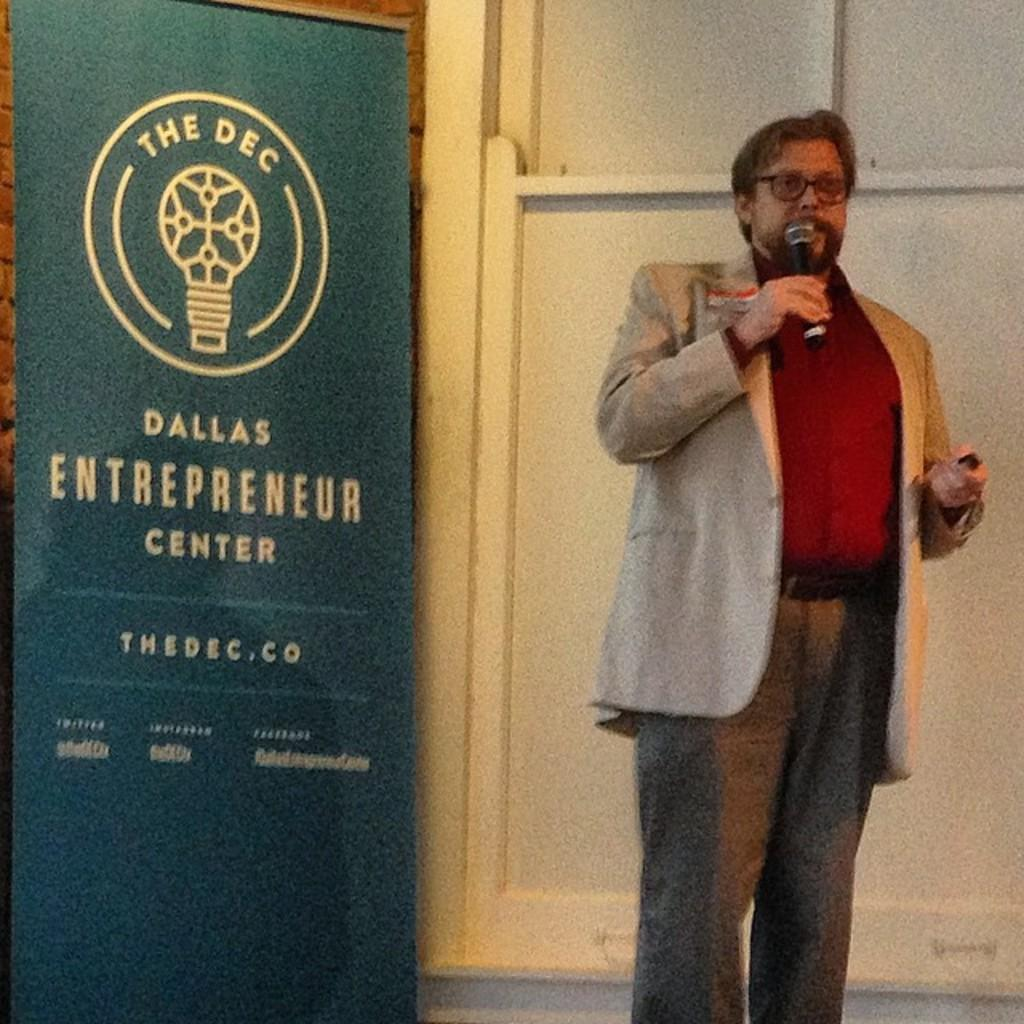Provide a one-sentence caption for the provided image. a man that is speaking next to a dallas entrepreneur sign. 